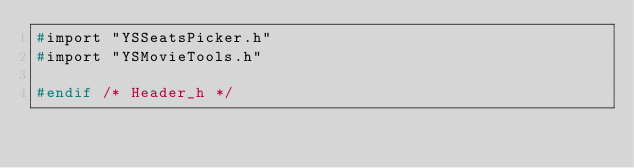Convert code to text. <code><loc_0><loc_0><loc_500><loc_500><_C_>#import "YSSeatsPicker.h"
#import "YSMovieTools.h"

#endif /* Header_h */
</code> 